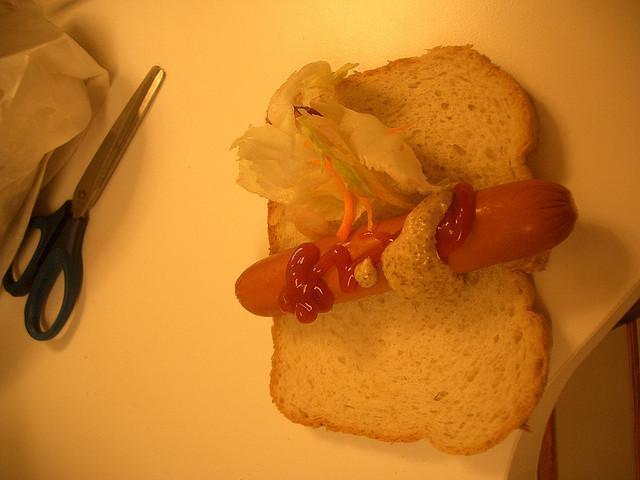How many people are wearing a blue hat?
Give a very brief answer. 0. 